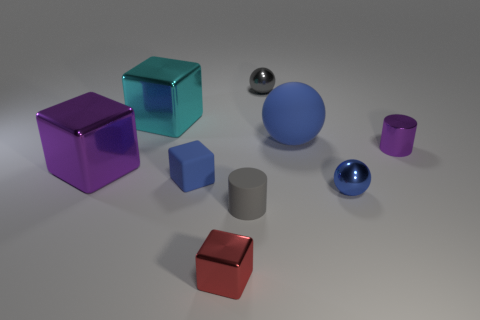Subtract all green cylinders. How many blue balls are left? 2 Subtract all cyan cubes. How many cubes are left? 3 Subtract all blue cubes. How many cubes are left? 3 Subtract all cylinders. How many objects are left? 7 Subtract 2 blocks. How many blocks are left? 2 Subtract all tiny cyan matte cylinders. Subtract all rubber cylinders. How many objects are left? 8 Add 5 tiny purple cylinders. How many tiny purple cylinders are left? 6 Add 9 tiny gray shiny objects. How many tiny gray shiny objects exist? 10 Subtract 0 yellow cylinders. How many objects are left? 9 Subtract all blue cubes. Subtract all gray balls. How many cubes are left? 3 